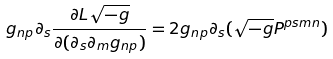Convert formula to latex. <formula><loc_0><loc_0><loc_500><loc_500>g _ { n p } \partial _ { s } \frac { \partial L \sqrt { - g } } { \partial ( \partial _ { s } \partial _ { m } g _ { n p } ) } = 2 g _ { n p } \partial _ { s } ( \sqrt { - g } P ^ { p s m n } )</formula> 